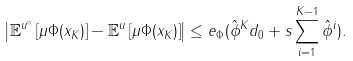<formula> <loc_0><loc_0><loc_500><loc_500>\left | \mathbb { E } ^ { u ^ { \circ } } \left [ \mu \Phi ( x _ { K } ) \right ] - \mathbb { E } ^ { u } \left [ \mu \Phi ( x _ { K } ) \right ] \right | \leq e _ { \Phi } ( \hat { \phi } ^ { K } d _ { 0 } + s \sum _ { i = 1 } ^ { K - 1 } \hat { \phi } ^ { i } ) .</formula> 